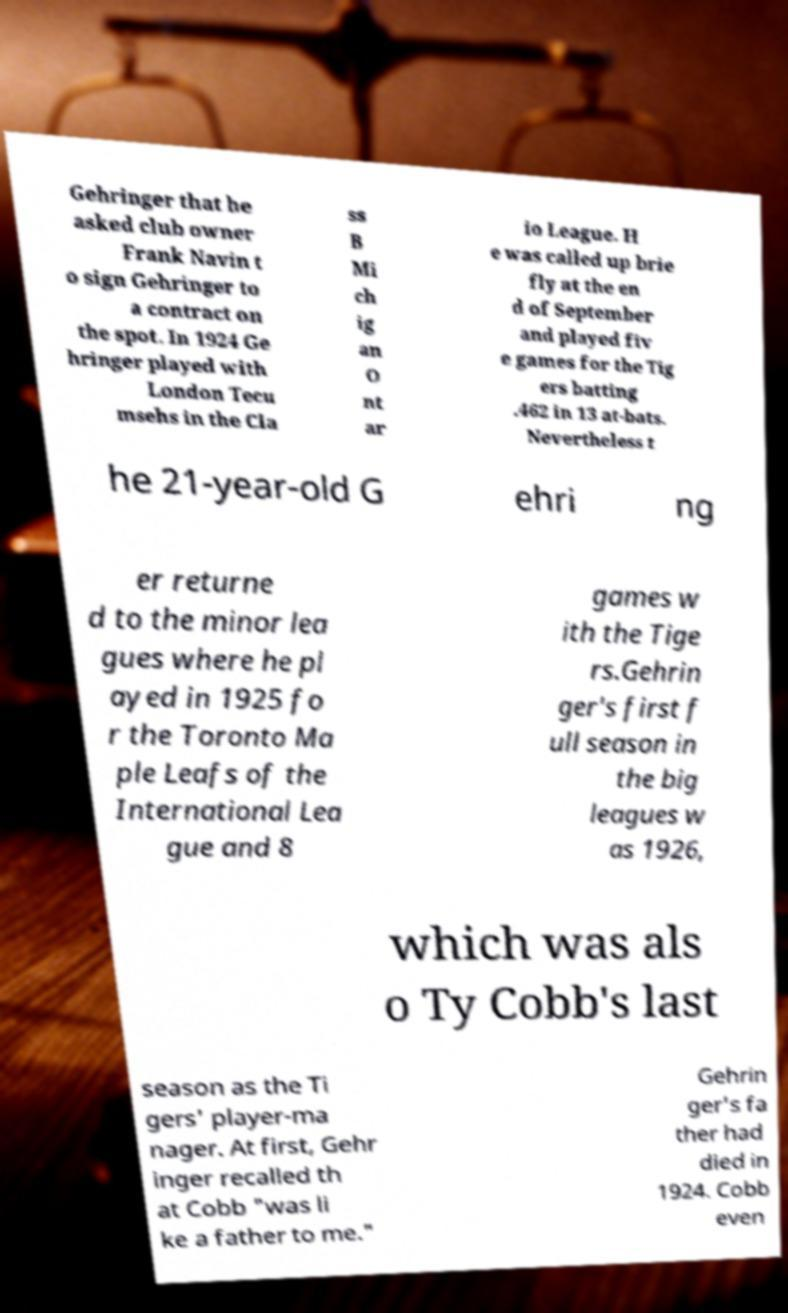For documentation purposes, I need the text within this image transcribed. Could you provide that? Gehringer that he asked club owner Frank Navin t o sign Gehringer to a contract on the spot. In 1924 Ge hringer played with London Tecu msehs in the Cla ss B Mi ch ig an O nt ar io League. H e was called up brie fly at the en d of September and played fiv e games for the Tig ers batting .462 in 13 at-bats. Nevertheless t he 21-year-old G ehri ng er returne d to the minor lea gues where he pl ayed in 1925 fo r the Toronto Ma ple Leafs of the International Lea gue and 8 games w ith the Tige rs.Gehrin ger's first f ull season in the big leagues w as 1926, which was als o Ty Cobb's last season as the Ti gers' player-ma nager. At first, Gehr inger recalled th at Cobb "was li ke a father to me." Gehrin ger's fa ther had died in 1924. Cobb even 